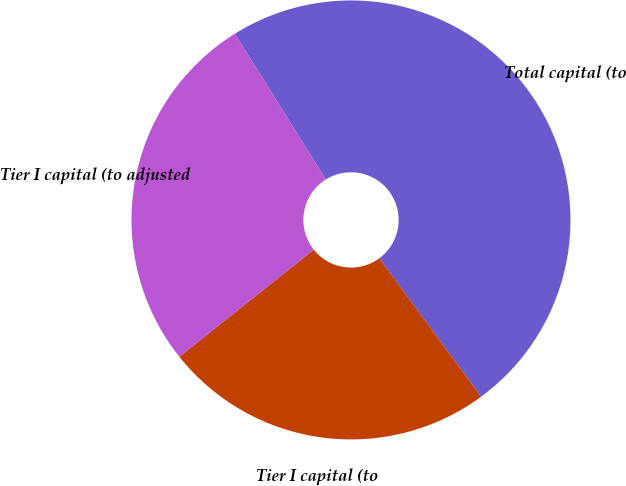<chart> <loc_0><loc_0><loc_500><loc_500><pie_chart><fcel>Total capital (to<fcel>Tier I capital (to<fcel>Tier I capital (to adjusted<nl><fcel>48.78%<fcel>24.39%<fcel>26.83%<nl></chart> 